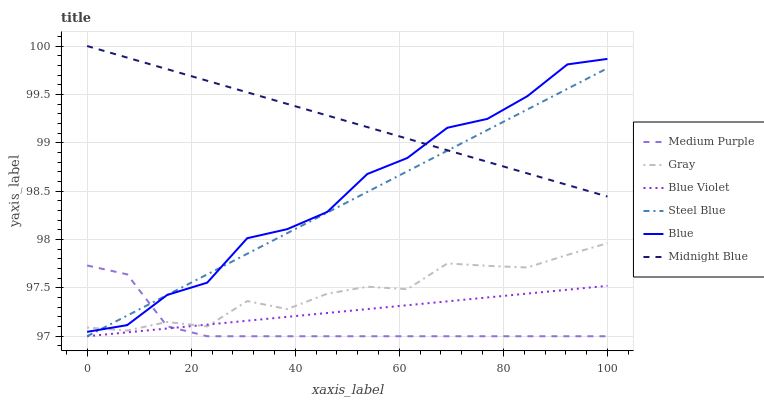Does Medium Purple have the minimum area under the curve?
Answer yes or no. Yes. Does Midnight Blue have the maximum area under the curve?
Answer yes or no. Yes. Does Gray have the minimum area under the curve?
Answer yes or no. No. Does Gray have the maximum area under the curve?
Answer yes or no. No. Is Blue Violet the smoothest?
Answer yes or no. Yes. Is Blue the roughest?
Answer yes or no. Yes. Is Gray the smoothest?
Answer yes or no. No. Is Gray the roughest?
Answer yes or no. No. Does Steel Blue have the lowest value?
Answer yes or no. Yes. Does Gray have the lowest value?
Answer yes or no. No. Does Midnight Blue have the highest value?
Answer yes or no. Yes. Does Gray have the highest value?
Answer yes or no. No. Is Medium Purple less than Midnight Blue?
Answer yes or no. Yes. Is Midnight Blue greater than Blue Violet?
Answer yes or no. Yes. Does Blue intersect Steel Blue?
Answer yes or no. Yes. Is Blue less than Steel Blue?
Answer yes or no. No. Is Blue greater than Steel Blue?
Answer yes or no. No. Does Medium Purple intersect Midnight Blue?
Answer yes or no. No. 